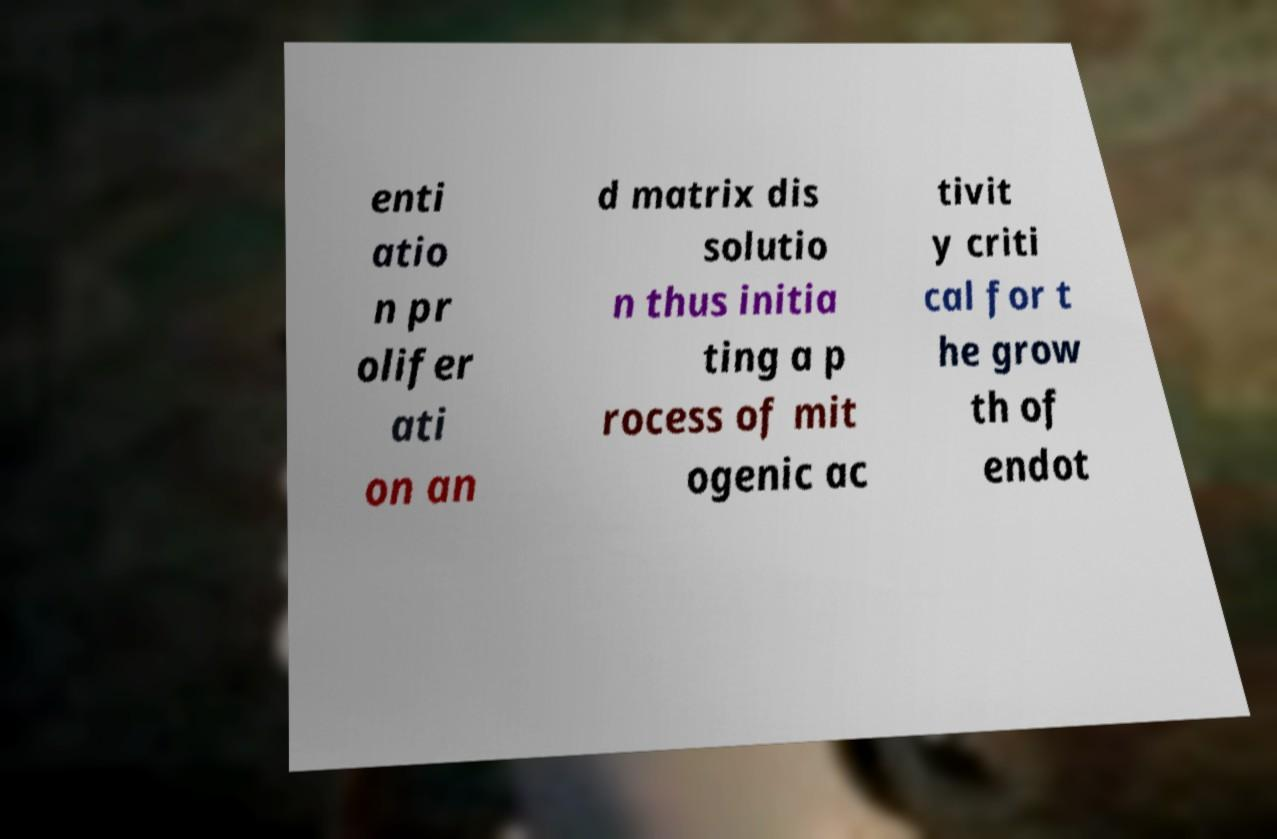I need the written content from this picture converted into text. Can you do that? enti atio n pr olifer ati on an d matrix dis solutio n thus initia ting a p rocess of mit ogenic ac tivit y criti cal for t he grow th of endot 